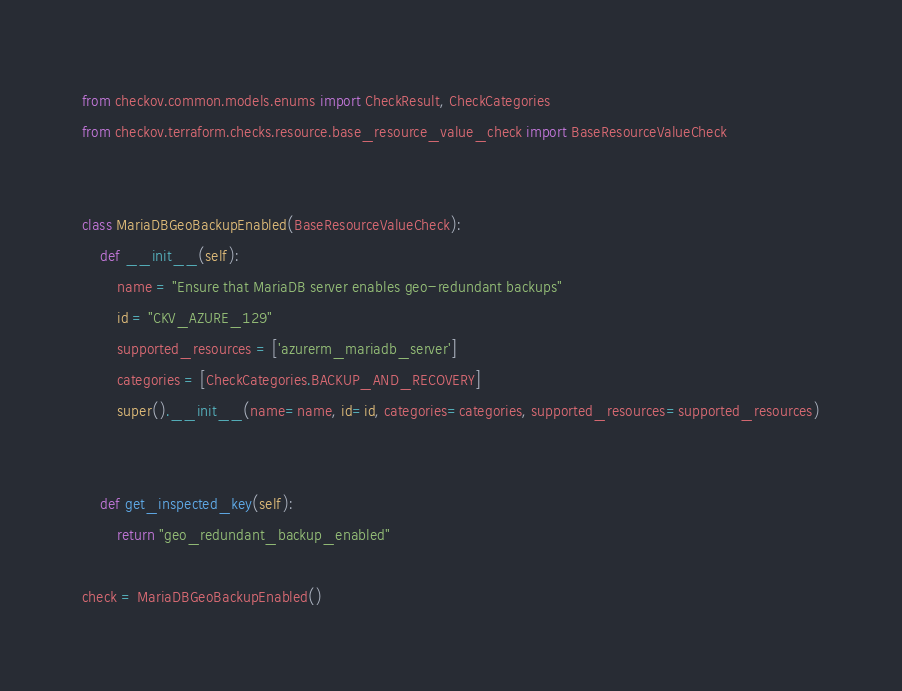<code> <loc_0><loc_0><loc_500><loc_500><_Python_>from checkov.common.models.enums import CheckResult, CheckCategories
from checkov.terraform.checks.resource.base_resource_value_check import BaseResourceValueCheck


class MariaDBGeoBackupEnabled(BaseResourceValueCheck):
    def __init__(self):
        name = "Ensure that MariaDB server enables geo-redundant backups"
        id = "CKV_AZURE_129"
        supported_resources = ['azurerm_mariadb_server']
        categories = [CheckCategories.BACKUP_AND_RECOVERY]
        super().__init__(name=name, id=id, categories=categories, supported_resources=supported_resources)

        
    def get_inspected_key(self):
        return "geo_redundant_backup_enabled"   

check = MariaDBGeoBackupEnabled()
</code> 